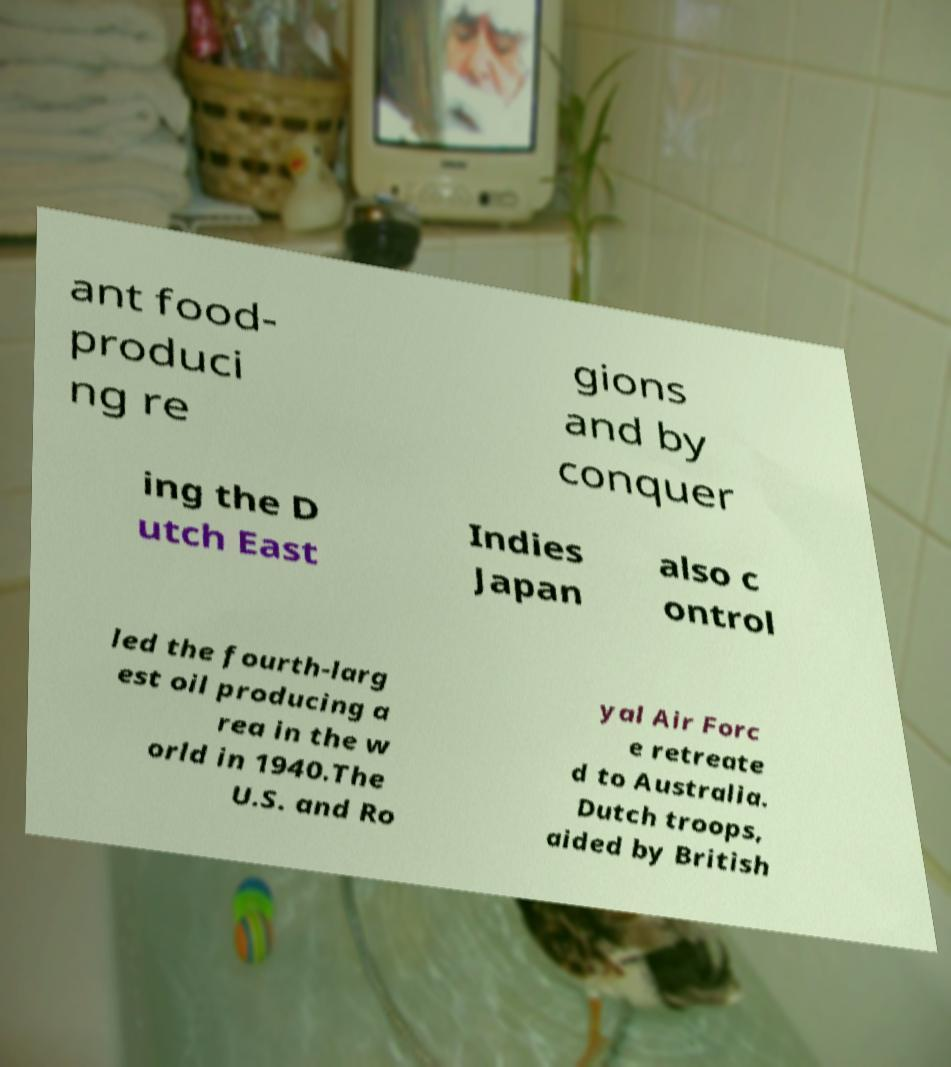There's text embedded in this image that I need extracted. Can you transcribe it verbatim? ant food- produci ng re gions and by conquer ing the D utch East Indies Japan also c ontrol led the fourth-larg est oil producing a rea in the w orld in 1940.The U.S. and Ro yal Air Forc e retreate d to Australia. Dutch troops, aided by British 